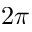<formula> <loc_0><loc_0><loc_500><loc_500>2 \pi</formula> 